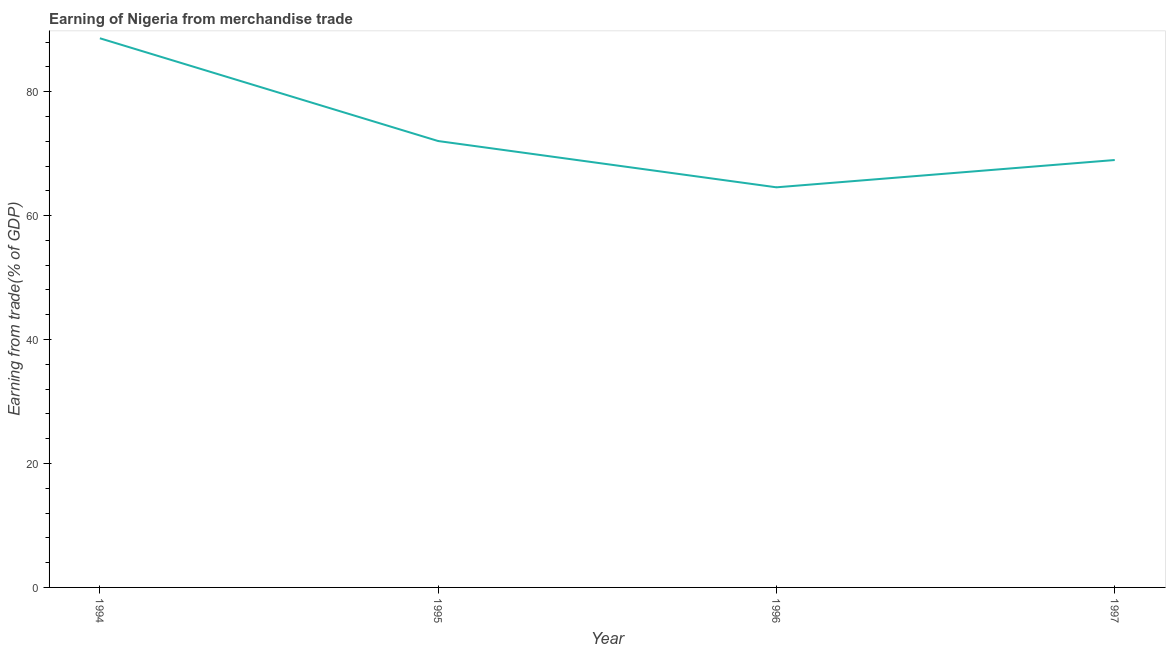What is the earning from merchandise trade in 1994?
Offer a terse response. 88.62. Across all years, what is the maximum earning from merchandise trade?
Keep it short and to the point. 88.62. Across all years, what is the minimum earning from merchandise trade?
Keep it short and to the point. 64.57. In which year was the earning from merchandise trade maximum?
Provide a succinct answer. 1994. In which year was the earning from merchandise trade minimum?
Your response must be concise. 1996. What is the sum of the earning from merchandise trade?
Your answer should be very brief. 294.2. What is the difference between the earning from merchandise trade in 1996 and 1997?
Your response must be concise. -4.41. What is the average earning from merchandise trade per year?
Your answer should be compact. 73.55. What is the median earning from merchandise trade?
Provide a short and direct response. 70.5. In how many years, is the earning from merchandise trade greater than 68 %?
Provide a succinct answer. 3. Do a majority of the years between 1996 and 1997 (inclusive) have earning from merchandise trade greater than 32 %?
Your response must be concise. Yes. What is the ratio of the earning from merchandise trade in 1995 to that in 1997?
Ensure brevity in your answer.  1.04. What is the difference between the highest and the second highest earning from merchandise trade?
Make the answer very short. 16.58. What is the difference between the highest and the lowest earning from merchandise trade?
Keep it short and to the point. 24.05. How many lines are there?
Your answer should be compact. 1. How many years are there in the graph?
Your answer should be compact. 4. Are the values on the major ticks of Y-axis written in scientific E-notation?
Your answer should be compact. No. Does the graph contain any zero values?
Your answer should be very brief. No. What is the title of the graph?
Keep it short and to the point. Earning of Nigeria from merchandise trade. What is the label or title of the X-axis?
Give a very brief answer. Year. What is the label or title of the Y-axis?
Your response must be concise. Earning from trade(% of GDP). What is the Earning from trade(% of GDP) in 1994?
Ensure brevity in your answer.  88.62. What is the Earning from trade(% of GDP) in 1995?
Provide a short and direct response. 72.04. What is the Earning from trade(% of GDP) of 1996?
Your answer should be compact. 64.57. What is the Earning from trade(% of GDP) in 1997?
Provide a short and direct response. 68.97. What is the difference between the Earning from trade(% of GDP) in 1994 and 1995?
Give a very brief answer. 16.58. What is the difference between the Earning from trade(% of GDP) in 1994 and 1996?
Make the answer very short. 24.05. What is the difference between the Earning from trade(% of GDP) in 1994 and 1997?
Keep it short and to the point. 19.65. What is the difference between the Earning from trade(% of GDP) in 1995 and 1996?
Your response must be concise. 7.47. What is the difference between the Earning from trade(% of GDP) in 1995 and 1997?
Your answer should be very brief. 3.06. What is the difference between the Earning from trade(% of GDP) in 1996 and 1997?
Provide a short and direct response. -4.41. What is the ratio of the Earning from trade(% of GDP) in 1994 to that in 1995?
Ensure brevity in your answer.  1.23. What is the ratio of the Earning from trade(% of GDP) in 1994 to that in 1996?
Keep it short and to the point. 1.37. What is the ratio of the Earning from trade(% of GDP) in 1994 to that in 1997?
Your answer should be compact. 1.28. What is the ratio of the Earning from trade(% of GDP) in 1995 to that in 1996?
Make the answer very short. 1.12. What is the ratio of the Earning from trade(% of GDP) in 1995 to that in 1997?
Your response must be concise. 1.04. What is the ratio of the Earning from trade(% of GDP) in 1996 to that in 1997?
Offer a terse response. 0.94. 